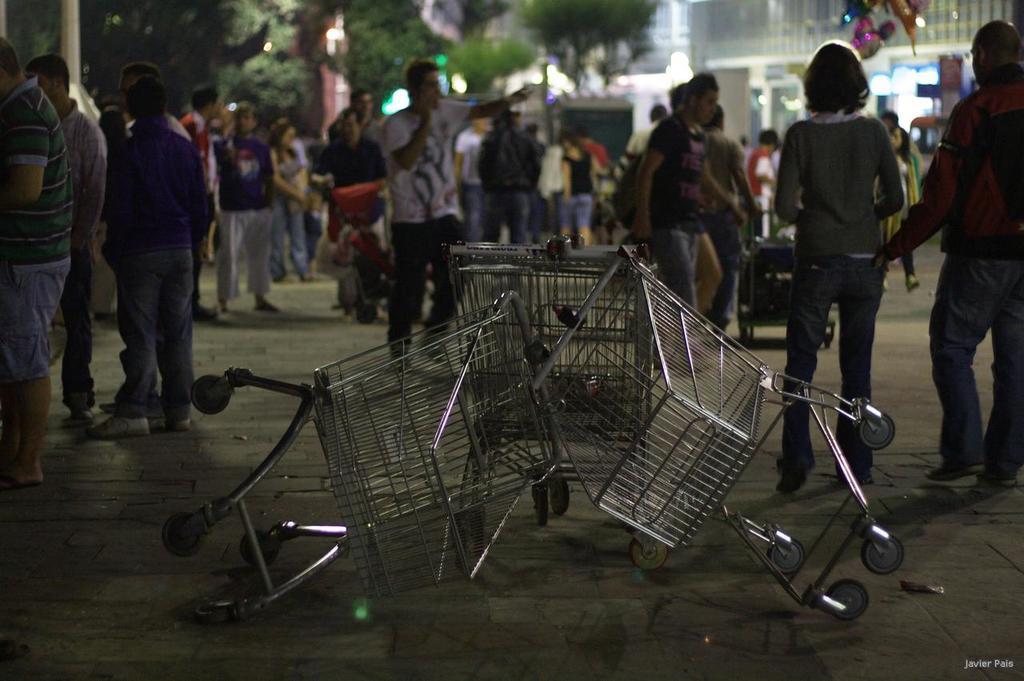How would you summarize this image in a sentence or two? In the picture silver color shopping trolleys on the ground. Behind there are many men and women, standing outside the mall. Behind there is a building and some trees. 